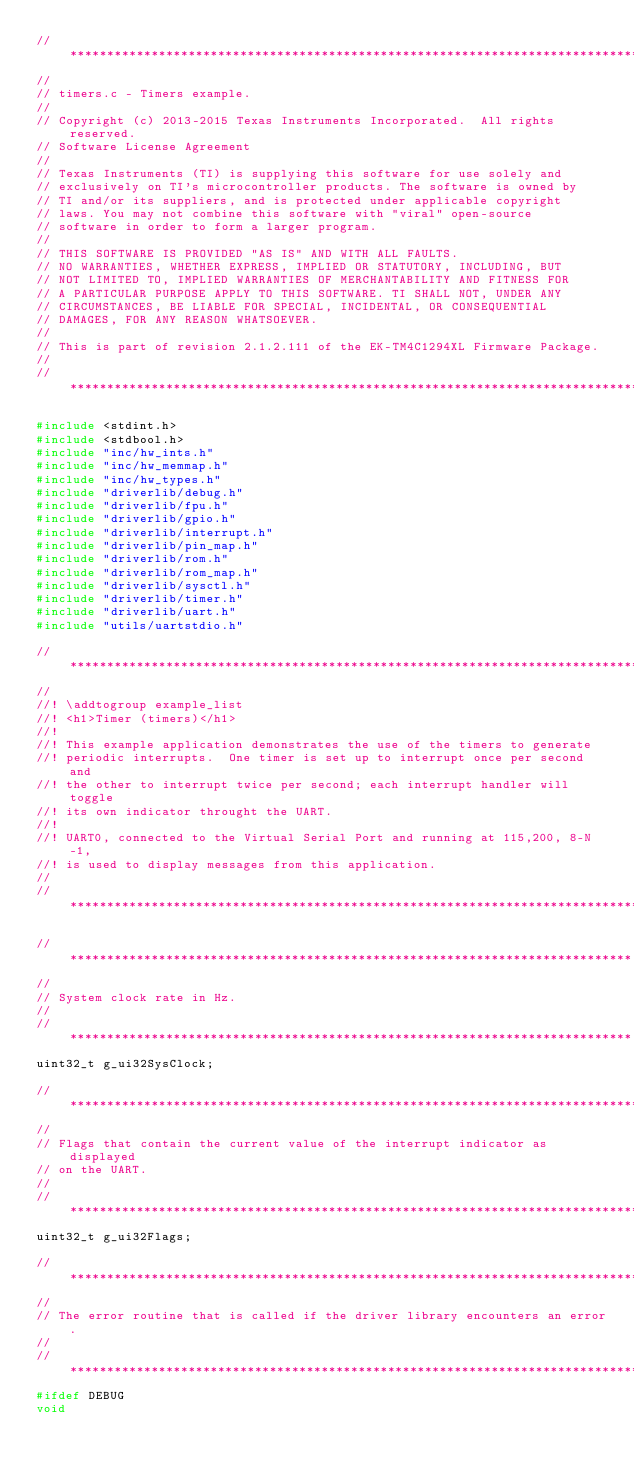Convert code to text. <code><loc_0><loc_0><loc_500><loc_500><_C_>//*****************************************************************************
//
// timers.c - Timers example.
//
// Copyright (c) 2013-2015 Texas Instruments Incorporated.  All rights reserved.
// Software License Agreement
//
// Texas Instruments (TI) is supplying this software for use solely and
// exclusively on TI's microcontroller products. The software is owned by
// TI and/or its suppliers, and is protected under applicable copyright
// laws. You may not combine this software with "viral" open-source
// software in order to form a larger program.
//
// THIS SOFTWARE IS PROVIDED "AS IS" AND WITH ALL FAULTS.
// NO WARRANTIES, WHETHER EXPRESS, IMPLIED OR STATUTORY, INCLUDING, BUT
// NOT LIMITED TO, IMPLIED WARRANTIES OF MERCHANTABILITY AND FITNESS FOR
// A PARTICULAR PURPOSE APPLY TO THIS SOFTWARE. TI SHALL NOT, UNDER ANY
// CIRCUMSTANCES, BE LIABLE FOR SPECIAL, INCIDENTAL, OR CONSEQUENTIAL
// DAMAGES, FOR ANY REASON WHATSOEVER.
//
// This is part of revision 2.1.2.111 of the EK-TM4C1294XL Firmware Package.
//
//*****************************************************************************

#include <stdint.h>
#include <stdbool.h>
#include "inc/hw_ints.h"
#include "inc/hw_memmap.h"
#include "inc/hw_types.h"
#include "driverlib/debug.h"
#include "driverlib/fpu.h"
#include "driverlib/gpio.h"
#include "driverlib/interrupt.h"
#include "driverlib/pin_map.h"
#include "driverlib/rom.h"
#include "driverlib/rom_map.h"
#include "driverlib/sysctl.h"
#include "driverlib/timer.h"
#include "driverlib/uart.h"
#include "utils/uartstdio.h"

//*****************************************************************************
//
//! \addtogroup example_list
//! <h1>Timer (timers)</h1>
//!
//! This example application demonstrates the use of the timers to generate
//! periodic interrupts.  One timer is set up to interrupt once per second and
//! the other to interrupt twice per second; each interrupt handler will toggle
//! its own indicator throught the UART.
//!
//! UART0, connected to the Virtual Serial Port and running at 115,200, 8-N-1,
//! is used to display messages from this application.
//
//*****************************************************************************

//****************************************************************************
//
// System clock rate in Hz.
//
//****************************************************************************
uint32_t g_ui32SysClock;

//*****************************************************************************
//
// Flags that contain the current value of the interrupt indicator as displayed
// on the UART.
//
//*****************************************************************************
uint32_t g_ui32Flags;

//*****************************************************************************
//
// The error routine that is called if the driver library encounters an error.
//
//*****************************************************************************
#ifdef DEBUG
void</code> 